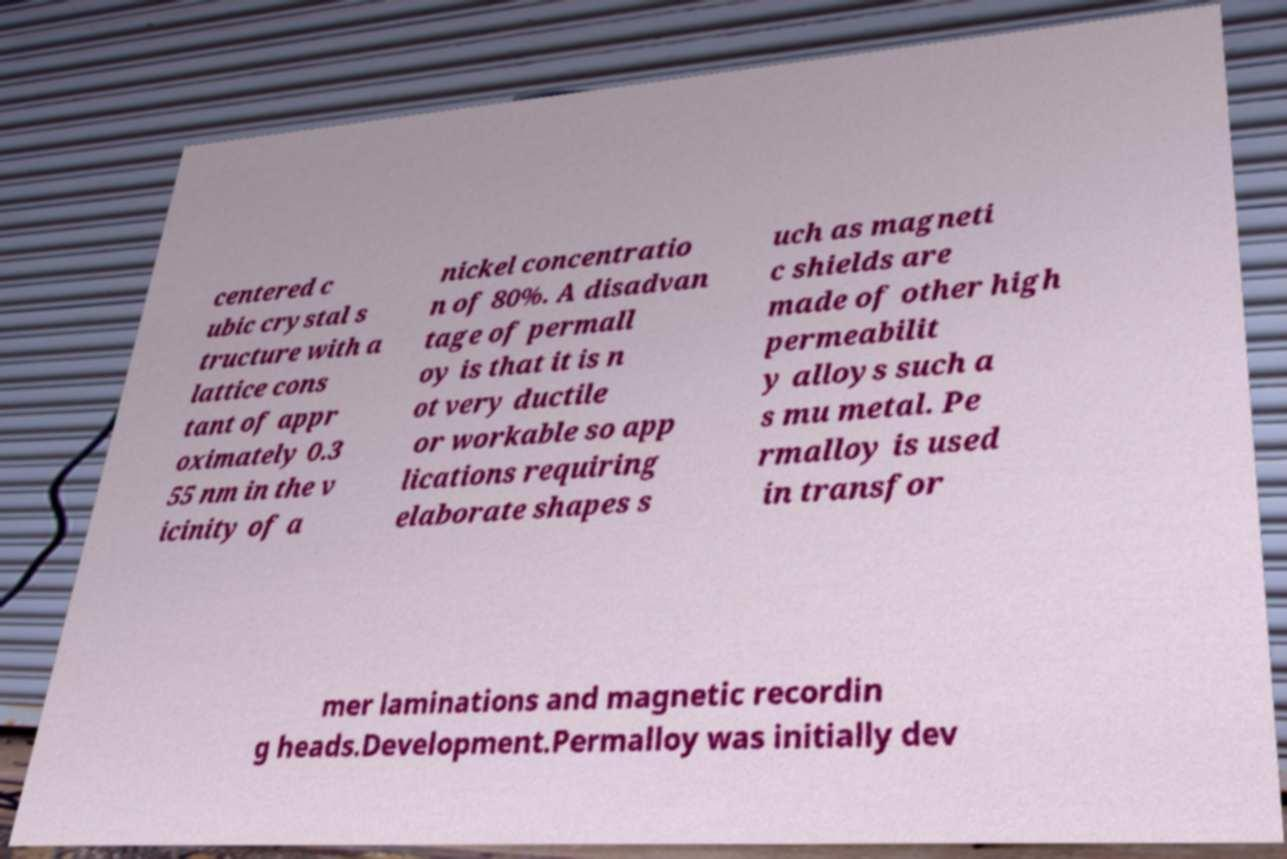Could you assist in decoding the text presented in this image and type it out clearly? centered c ubic crystal s tructure with a lattice cons tant of appr oximately 0.3 55 nm in the v icinity of a nickel concentratio n of 80%. A disadvan tage of permall oy is that it is n ot very ductile or workable so app lications requiring elaborate shapes s uch as magneti c shields are made of other high permeabilit y alloys such a s mu metal. Pe rmalloy is used in transfor mer laminations and magnetic recordin g heads.Development.Permalloy was initially dev 